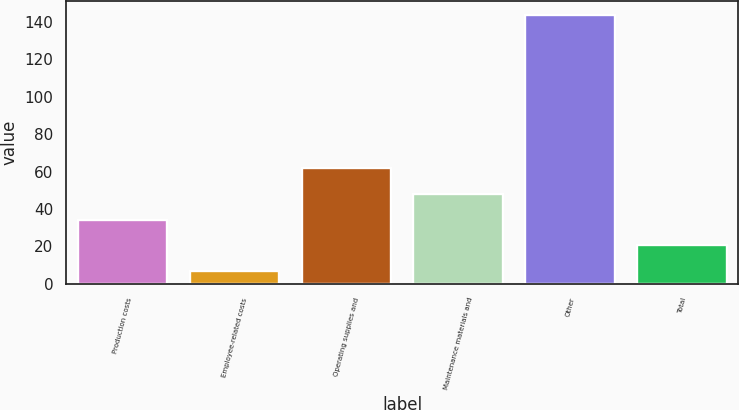Convert chart to OTSL. <chart><loc_0><loc_0><loc_500><loc_500><bar_chart><fcel>Production costs<fcel>Employee-related costs<fcel>Operating supplies and<fcel>Maintenance materials and<fcel>Other<fcel>Total<nl><fcel>34.28<fcel>6.9<fcel>61.66<fcel>47.97<fcel>143.8<fcel>20.59<nl></chart> 